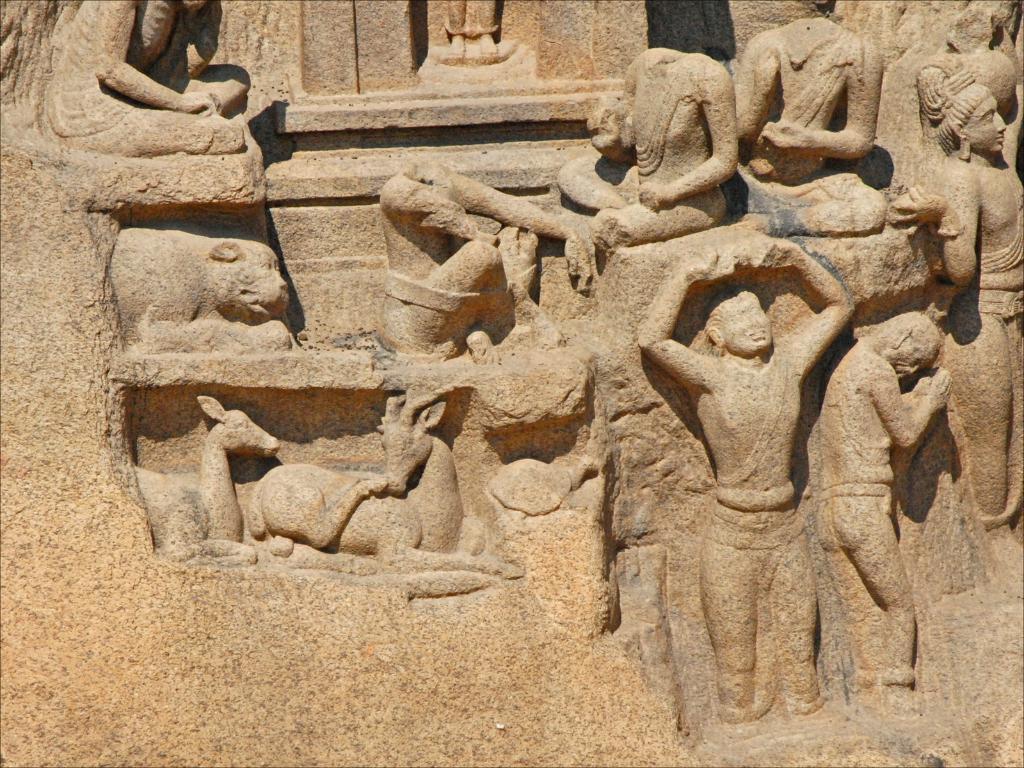Can you describe this image briefly? In the picture I can see sculptures of people and animals on the wall. 